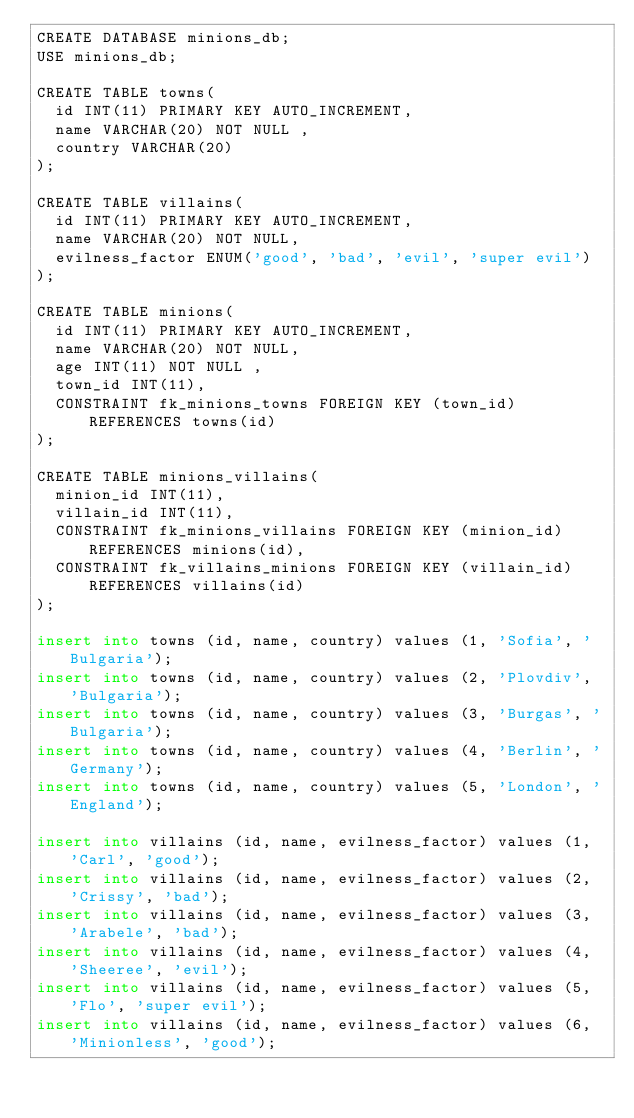Convert code to text. <code><loc_0><loc_0><loc_500><loc_500><_SQL_>CREATE DATABASE minions_db;
USE minions_db;

CREATE TABLE towns(
  id INT(11) PRIMARY KEY AUTO_INCREMENT,
  name VARCHAR(20) NOT NULL ,
  country VARCHAR(20)
);

CREATE TABLE villains(
  id INT(11) PRIMARY KEY AUTO_INCREMENT,
  name VARCHAR(20) NOT NULL,
  evilness_factor ENUM('good', 'bad', 'evil', 'super evil')
);

CREATE TABLE minions(
  id INT(11) PRIMARY KEY AUTO_INCREMENT,
  name VARCHAR(20) NOT NULL,
  age INT(11) NOT NULL ,
  town_id INT(11),
  CONSTRAINT fk_minions_towns FOREIGN KEY (town_id) REFERENCES towns(id)
);

CREATE TABLE minions_villains(
  minion_id INT(11),
  villain_id INT(11),
  CONSTRAINT fk_minions_villains FOREIGN KEY (minion_id) REFERENCES minions(id),
  CONSTRAINT fk_villains_minions FOREIGN KEY (villain_id) REFERENCES villains(id)
);

insert into towns (id, name, country) values (1, 'Sofia', 'Bulgaria');
insert into towns (id, name, country) values (2, 'Plovdiv', 'Bulgaria');
insert into towns (id, name, country) values (3, 'Burgas', 'Bulgaria');
insert into towns (id, name, country) values (4, 'Berlin', 'Germany');
insert into towns (id, name, country) values (5, 'London', 'England');

insert into villains (id, name, evilness_factor) values (1, 'Carl', 'good');
insert into villains (id, name, evilness_factor) values (2, 'Crissy', 'bad');
insert into villains (id, name, evilness_factor) values (3, 'Arabele', 'bad');
insert into villains (id, name, evilness_factor) values (4, 'Sheeree', 'evil');
insert into villains (id, name, evilness_factor) values (5, 'Flo', 'super evil');
insert into villains (id, name, evilness_factor) values (6, 'Minionless', 'good');
</code> 